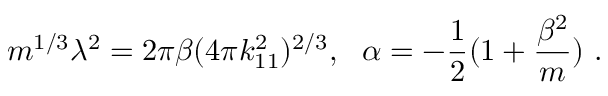Convert formula to latex. <formula><loc_0><loc_0><loc_500><loc_500>m ^ { 1 / 3 } \lambda ^ { 2 } = 2 \pi \beta ( 4 \pi k _ { 1 1 } ^ { 2 } ) ^ { 2 / 3 } , \quad a l p h a = - { \frac { 1 } { 2 } } ( 1 + { \frac { \beta ^ { 2 } } { m } } ) \ .</formula> 